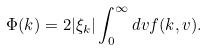Convert formula to latex. <formula><loc_0><loc_0><loc_500><loc_500>\Phi ( { k } ) = 2 | \xi _ { k } | \int _ { 0 } ^ { \infty } d v f ( { k } , v ) .</formula> 